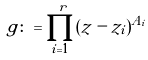<formula> <loc_0><loc_0><loc_500><loc_500>g \colon = \prod _ { i = 1 } ^ { r } ( z - z _ { i } ) ^ { A _ { i } }</formula> 